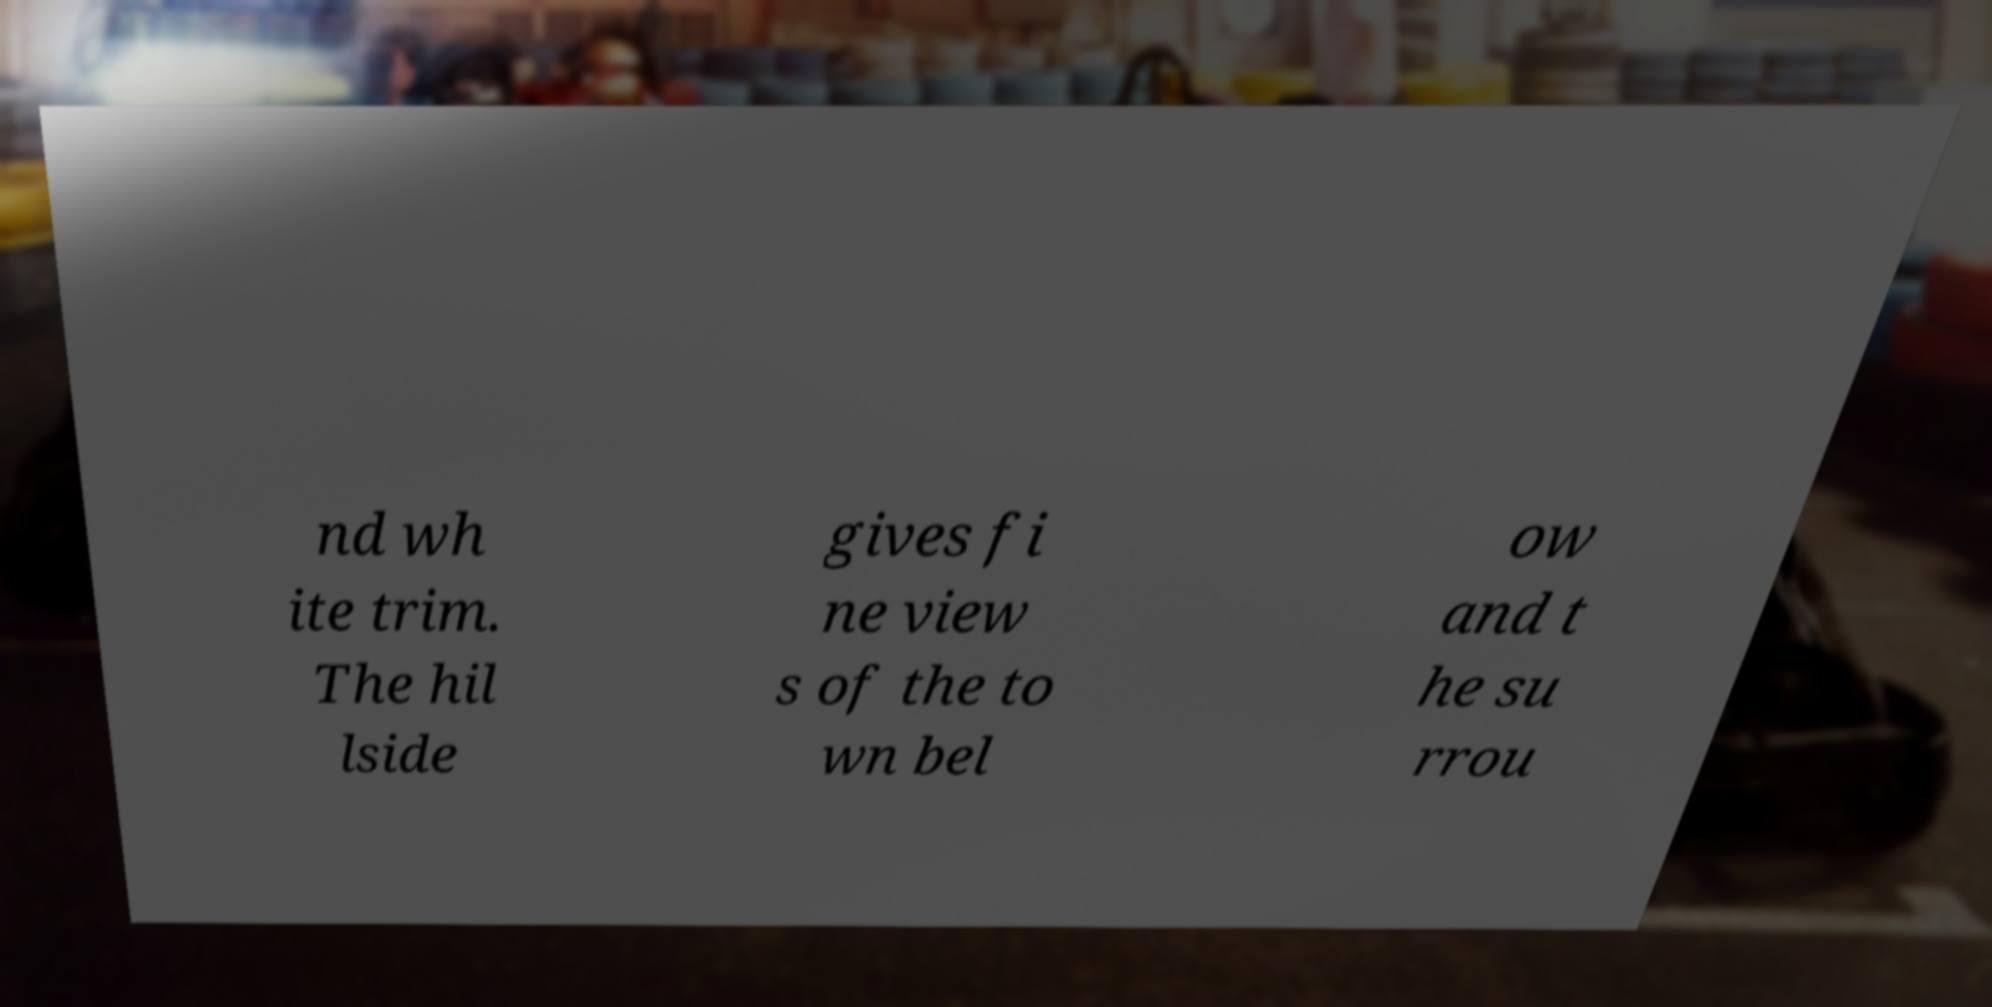There's text embedded in this image that I need extracted. Can you transcribe it verbatim? nd wh ite trim. The hil lside gives fi ne view s of the to wn bel ow and t he su rrou 